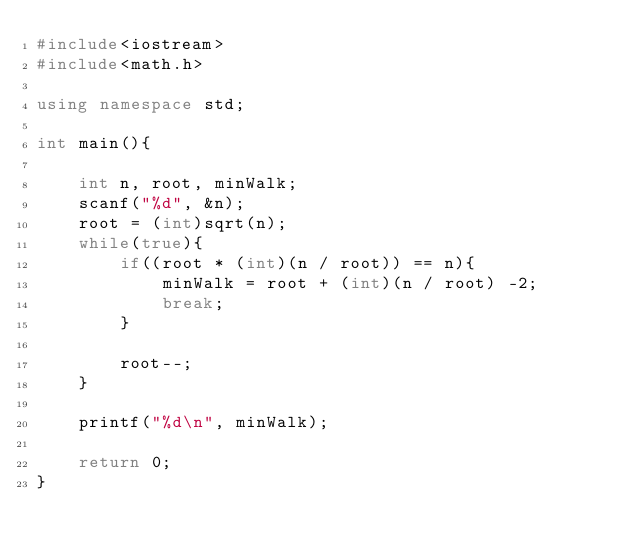<code> <loc_0><loc_0><loc_500><loc_500><_C++_>#include<iostream>
#include<math.h>

using namespace std;

int main(){

    int n, root, minWalk;
    scanf("%d", &n);
    root = (int)sqrt(n);
    while(true){
        if((root * (int)(n / root)) == n){
            minWalk = root + (int)(n / root) -2;
            break;
        }

        root--;
    }

    printf("%d\n", minWalk);

    return 0;
}</code> 